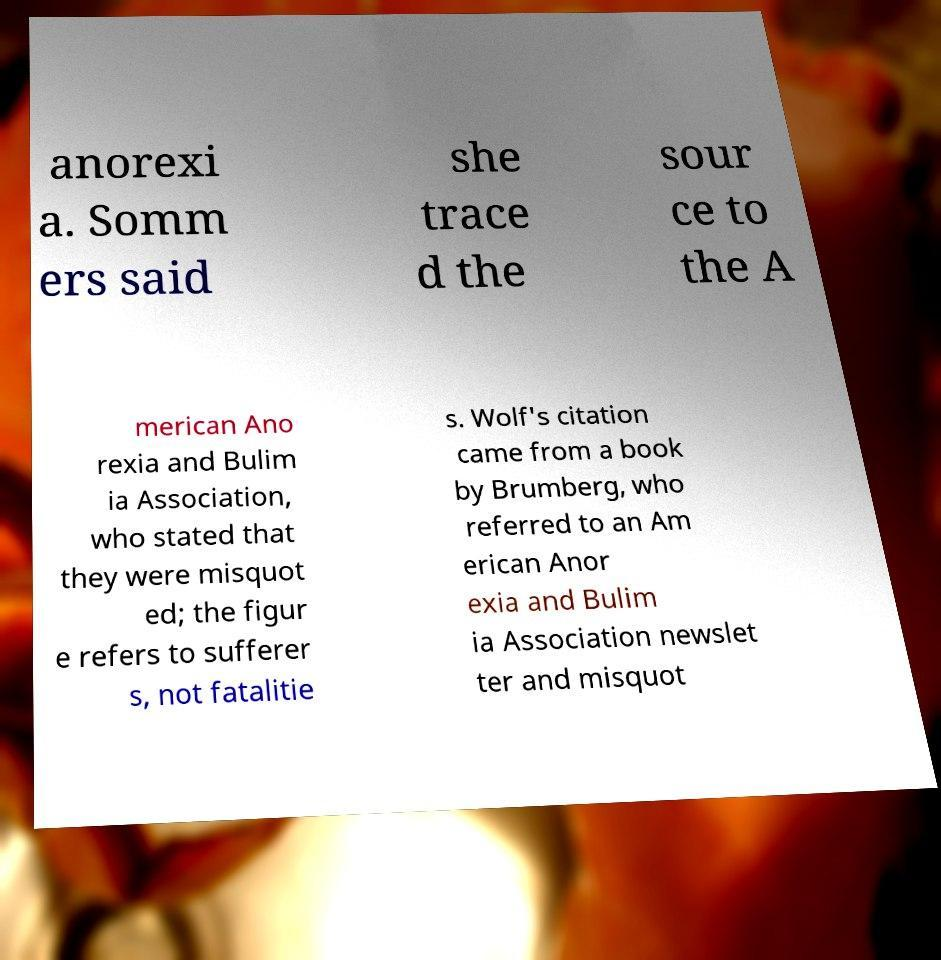For documentation purposes, I need the text within this image transcribed. Could you provide that? anorexi a. Somm ers said she trace d the sour ce to the A merican Ano rexia and Bulim ia Association, who stated that they were misquot ed; the figur e refers to sufferer s, not fatalitie s. Wolf's citation came from a book by Brumberg, who referred to an Am erican Anor exia and Bulim ia Association newslet ter and misquot 